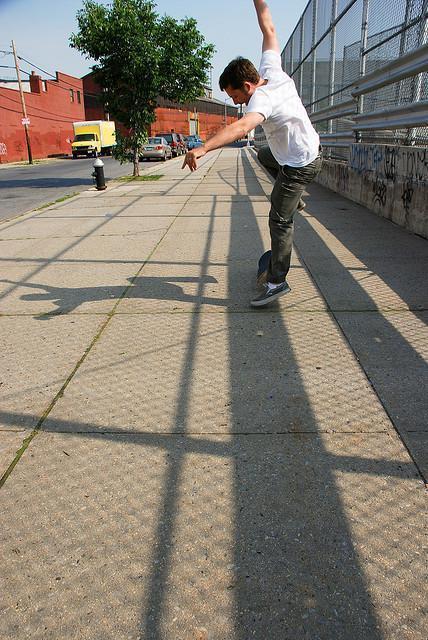The shadow of what is visible?
Indicate the correct choice and explain in the format: 'Answer: answer
Rationale: rationale.'
Options: Skateboarder, bird, tank, cow. Answer: skateboarder.
Rationale: The shadow of the person on the skateboarding can be seen on the ground. 